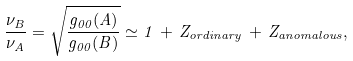<formula> <loc_0><loc_0><loc_500><loc_500>\frac { \nu _ { B } } { \nu _ { A } } = \sqrt { \frac { g _ { 0 0 } ( A ) } { g _ { 0 0 } ( B ) } } \simeq 1 \, + \, Z _ { o r d i n a r y } \, + \, Z _ { a n o m a l o u s } ,</formula> 